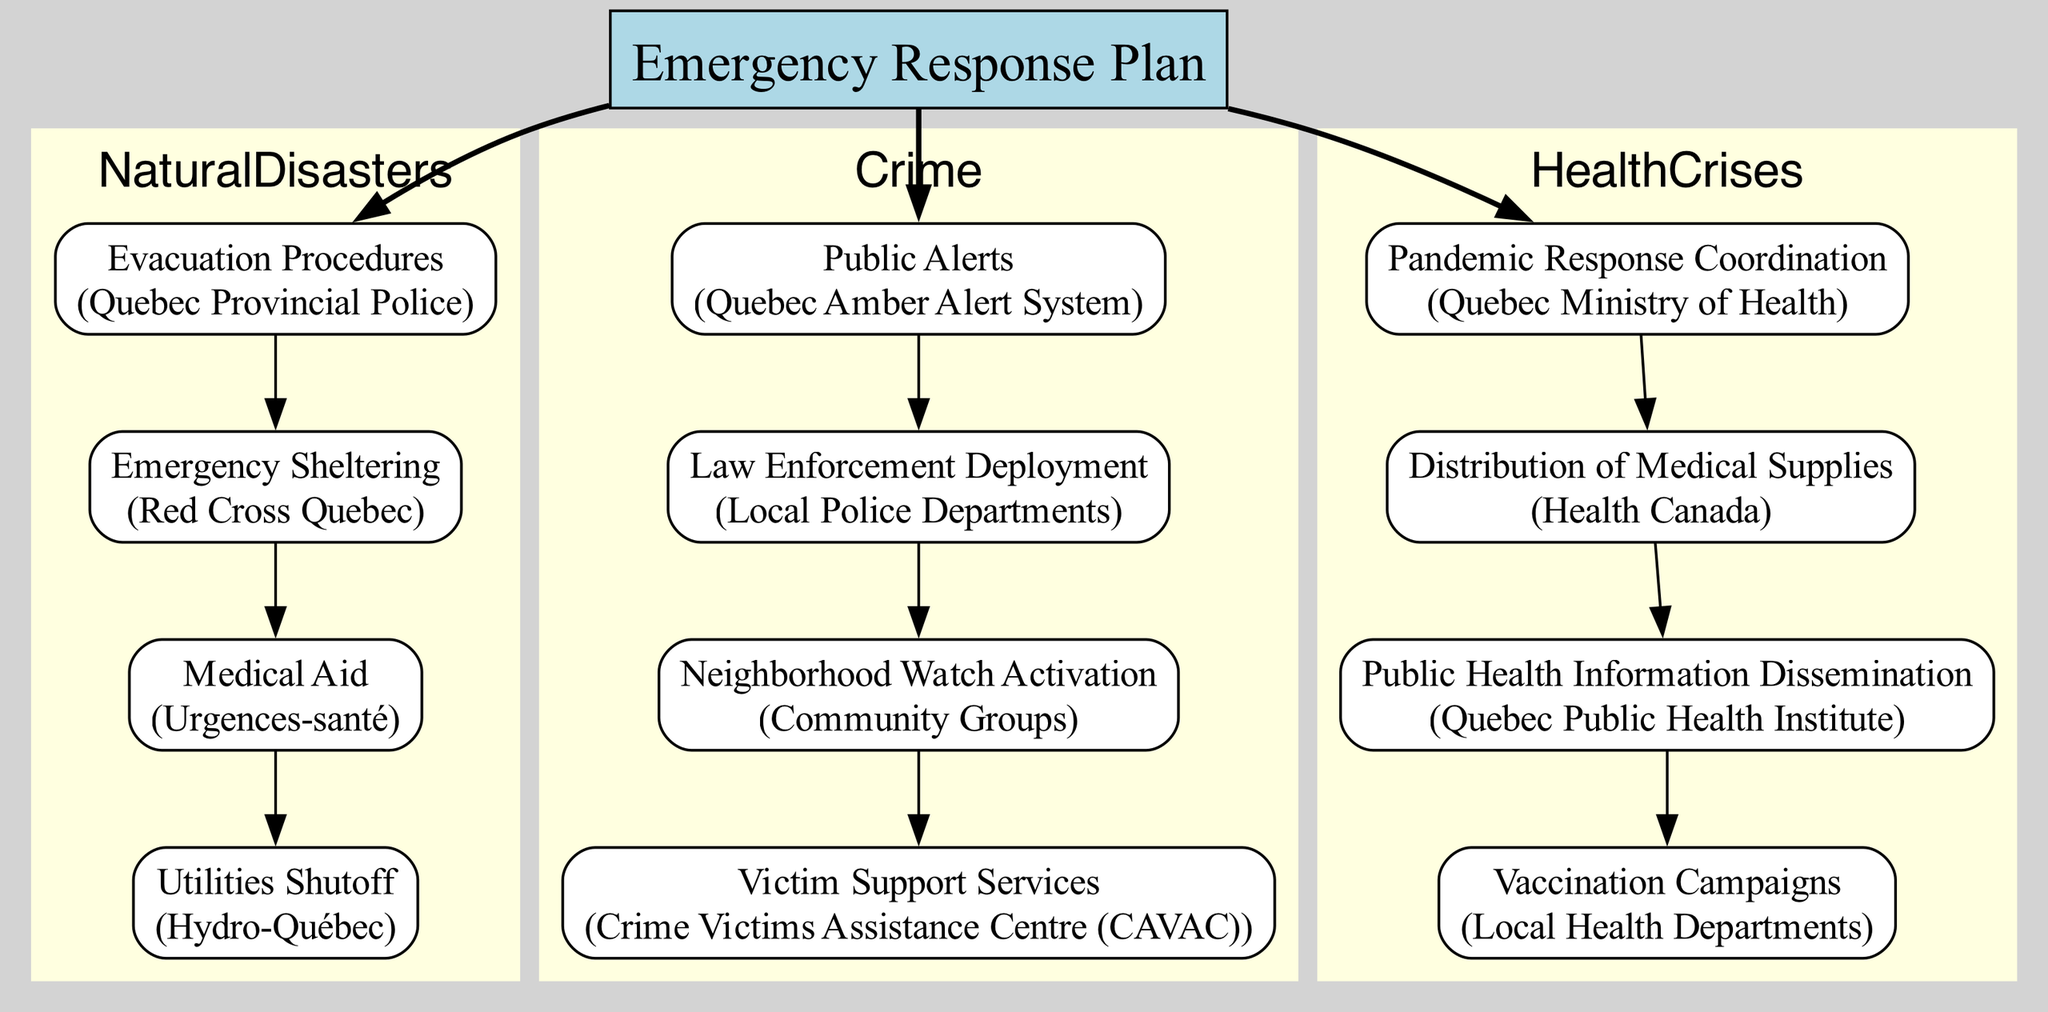What actions are taken under Natural Disasters? The diagram outlines the actions related to Natural Disasters, which include Evacuation Procedures, Emergency Sheltering, Medical Aid, and Utilities Shutoff.
Answer: Evacuation Procedures, Emergency Sheltering, Medical Aid, Utilities Shutoff How many actions are assigned to Crime? By examining the cluster for Crime, we see there are four actions listed: Public Alerts, Law Enforcement Deployment, Neighborhood Watch Activation, and Victim Support Services. This results in an overall count of four actions.
Answer: 4 Who is responsible for Emergency Sheltering? Within the Natural Disasters cluster, the action of Emergency Sheltering is assigned to Red Cross Quebec. This can be found by locating the specific action within the cluster for Natural Disasters.
Answer: Red Cross Quebec What is the first action listed under Health Crises? The first action in the Health Crises section is Pandemic Response Coordination. This identifies the initial response action taken for health-related emergencies.
Answer: Pandemic Response Coordination Which agency is responsible for Public Alerts in the event of Crime? Within the Crime section of the diagram, Public Alerts is specifically assigned to the Quebec Amber Alert System, indicating the agency's role in crime-related emergencies.
Answer: Quebec Amber Alert System Which action involves local health departments? The action of Vaccination Campaigns is under the Health Crises section, and it is explicitly indicated that Local Health Departments are responsible for this action.
Answer: Vaccination Campaigns How many agencies are involved in responding to Health Crises? In the Health Crises category, there are four distinct actions, each assigned to a different agency: Quebec Ministry of Health, Health Canada, Quebec Public Health Institute, and Local Health Departments. Thus, there are four agencies involved.
Answer: 4 What connection does the Utilities Shutoff action have? Utilities Shutoff is connected to the Emergency Response Plan as its initiating node in the Natural Disasters cluster. It directly flows from the main node, creating a direct link within the diagram structure.
Answer: Direct link to Emergency Response Plan What follows Law Enforcement Deployment in the Crime section? Following the action of Law Enforcement Deployment in the Crime section, the next action is Neighborhood Watch Activation, thereby indicating a sequential response process within the diagram.
Answer: Neighborhood Watch Activation 